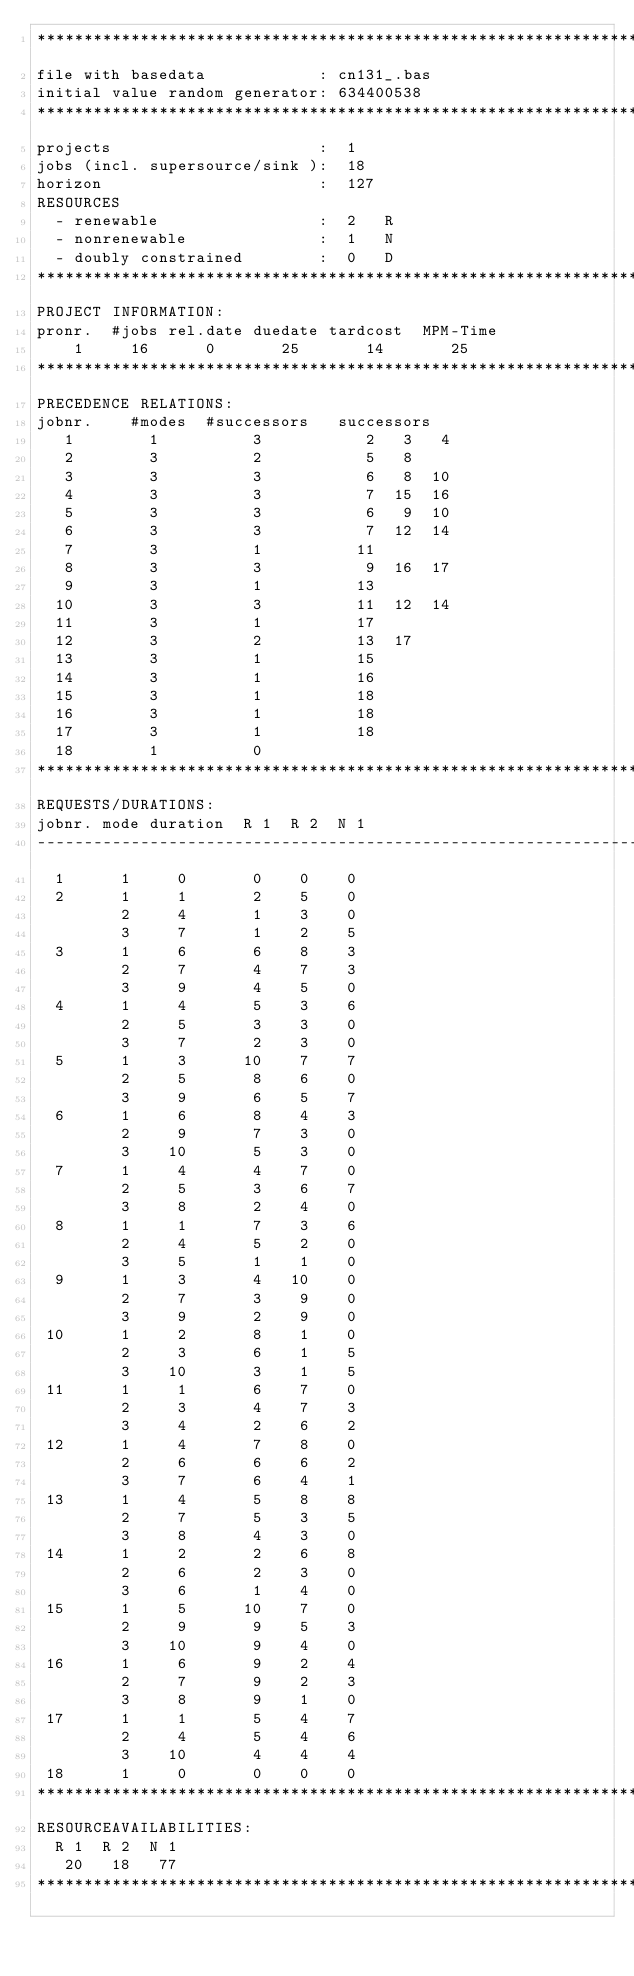<code> <loc_0><loc_0><loc_500><loc_500><_ObjectiveC_>************************************************************************
file with basedata            : cn131_.bas
initial value random generator: 634400538
************************************************************************
projects                      :  1
jobs (incl. supersource/sink ):  18
horizon                       :  127
RESOURCES
  - renewable                 :  2   R
  - nonrenewable              :  1   N
  - doubly constrained        :  0   D
************************************************************************
PROJECT INFORMATION:
pronr.  #jobs rel.date duedate tardcost  MPM-Time
    1     16      0       25       14       25
************************************************************************
PRECEDENCE RELATIONS:
jobnr.    #modes  #successors   successors
   1        1          3           2   3   4
   2        3          2           5   8
   3        3          3           6   8  10
   4        3          3           7  15  16
   5        3          3           6   9  10
   6        3          3           7  12  14
   7        3          1          11
   8        3          3           9  16  17
   9        3          1          13
  10        3          3          11  12  14
  11        3          1          17
  12        3          2          13  17
  13        3          1          15
  14        3          1          16
  15        3          1          18
  16        3          1          18
  17        3          1          18
  18        1          0        
************************************************************************
REQUESTS/DURATIONS:
jobnr. mode duration  R 1  R 2  N 1
------------------------------------------------------------------------
  1      1     0       0    0    0
  2      1     1       2    5    0
         2     4       1    3    0
         3     7       1    2    5
  3      1     6       6    8    3
         2     7       4    7    3
         3     9       4    5    0
  4      1     4       5    3    6
         2     5       3    3    0
         3     7       2    3    0
  5      1     3      10    7    7
         2     5       8    6    0
         3     9       6    5    7
  6      1     6       8    4    3
         2     9       7    3    0
         3    10       5    3    0
  7      1     4       4    7    0
         2     5       3    6    7
         3     8       2    4    0
  8      1     1       7    3    6
         2     4       5    2    0
         3     5       1    1    0
  9      1     3       4   10    0
         2     7       3    9    0
         3     9       2    9    0
 10      1     2       8    1    0
         2     3       6    1    5
         3    10       3    1    5
 11      1     1       6    7    0
         2     3       4    7    3
         3     4       2    6    2
 12      1     4       7    8    0
         2     6       6    6    2
         3     7       6    4    1
 13      1     4       5    8    8
         2     7       5    3    5
         3     8       4    3    0
 14      1     2       2    6    8
         2     6       2    3    0
         3     6       1    4    0
 15      1     5      10    7    0
         2     9       9    5    3
         3    10       9    4    0
 16      1     6       9    2    4
         2     7       9    2    3
         3     8       9    1    0
 17      1     1       5    4    7
         2     4       5    4    6
         3    10       4    4    4
 18      1     0       0    0    0
************************************************************************
RESOURCEAVAILABILITIES:
  R 1  R 2  N 1
   20   18   77
************************************************************************
</code> 